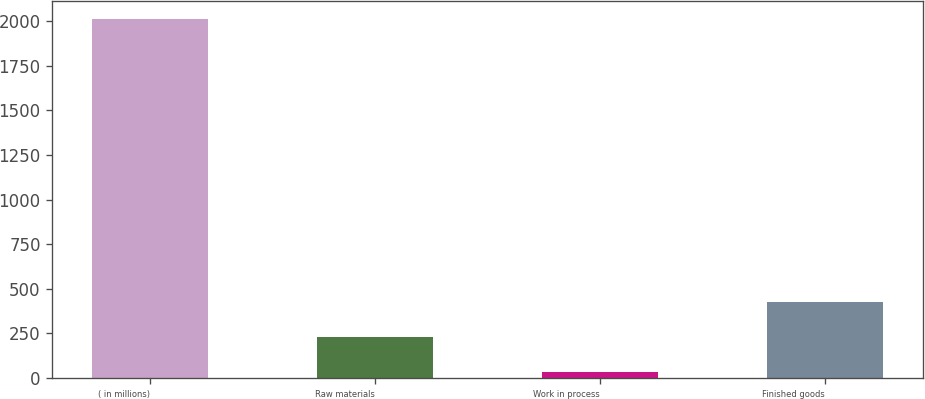Convert chart to OTSL. <chart><loc_0><loc_0><loc_500><loc_500><bar_chart><fcel>( in millions)<fcel>Raw materials<fcel>Work in process<fcel>Finished goods<nl><fcel>2015<fcel>228.59<fcel>30.1<fcel>427.08<nl></chart> 